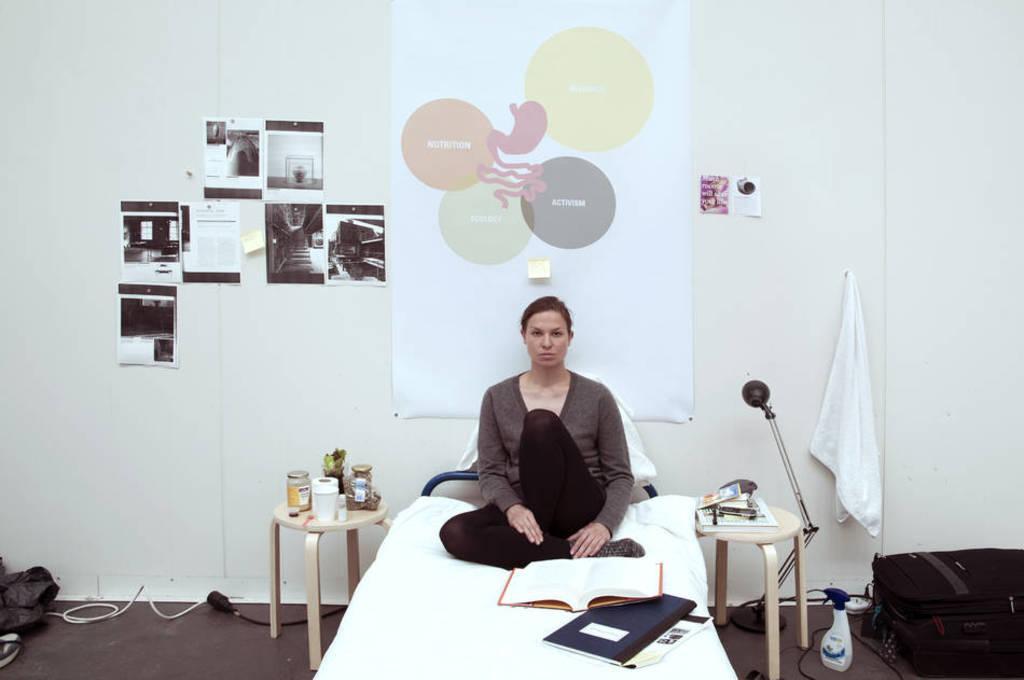In one or two sentences, can you explain what this image depicts? In this picture we can see a woman sitting on the bed. These are the books. There is a table. On the table there are some bottles. This is the floor. On the background there is a wall. And these are the posters. Here we can see a bottle. And this is the briefcase. 